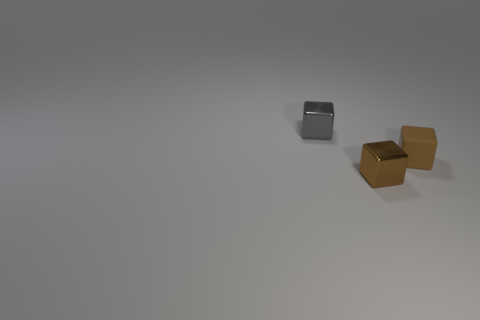Add 3 small blue matte cylinders. How many objects exist? 6 Subtract all large brown cubes. Subtract all brown rubber cubes. How many objects are left? 2 Add 3 metal blocks. How many metal blocks are left? 5 Add 2 small things. How many small things exist? 5 Subtract 0 blue spheres. How many objects are left? 3 